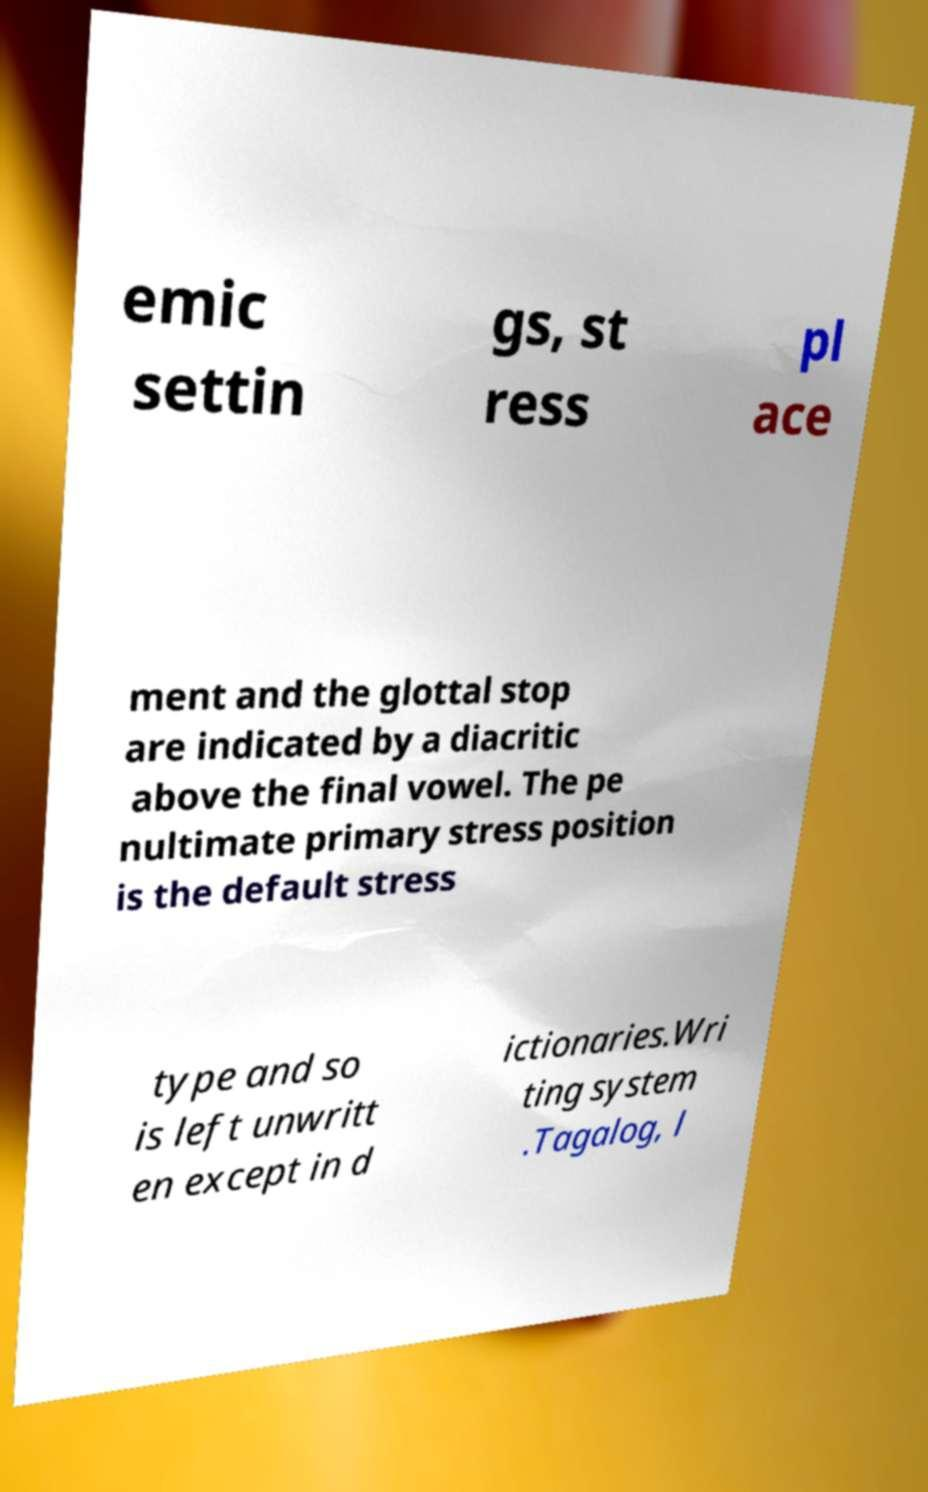There's text embedded in this image that I need extracted. Can you transcribe it verbatim? emic settin gs, st ress pl ace ment and the glottal stop are indicated by a diacritic above the final vowel. The pe nultimate primary stress position is the default stress type and so is left unwritt en except in d ictionaries.Wri ting system .Tagalog, l 